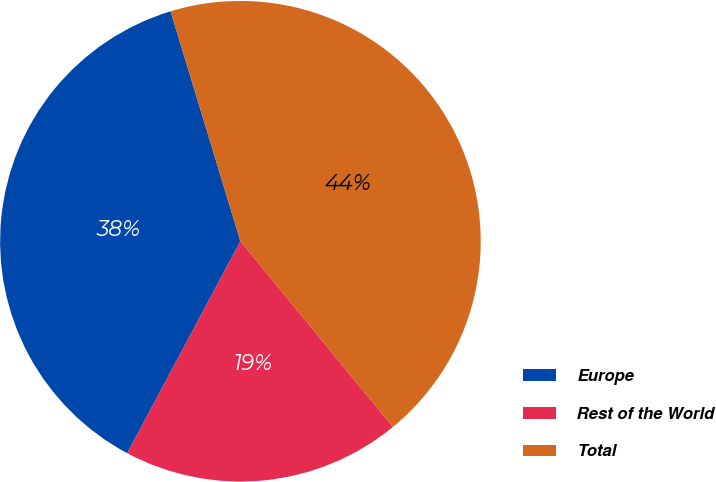Convert chart to OTSL. <chart><loc_0><loc_0><loc_500><loc_500><pie_chart><fcel>Europe<fcel>Rest of the World<fcel>Total<nl><fcel>37.5%<fcel>18.75%<fcel>43.75%<nl></chart> 